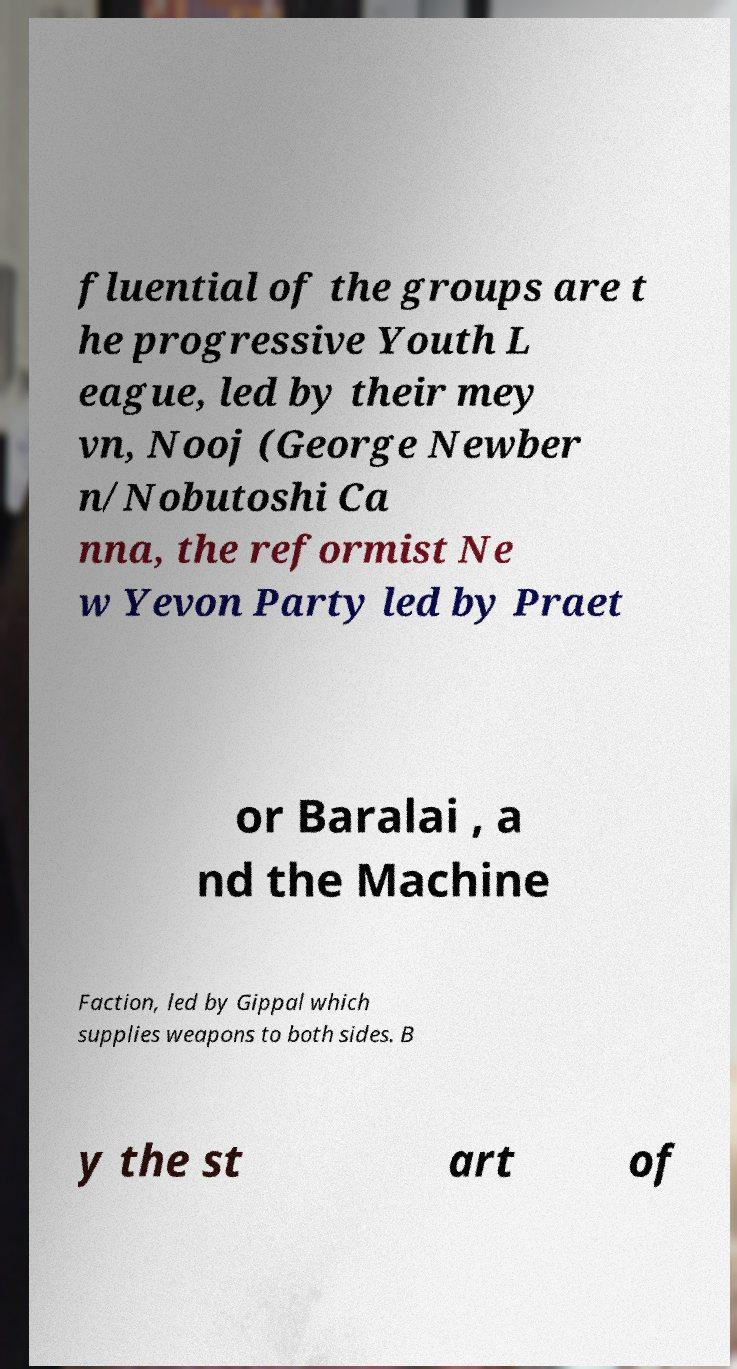Please read and relay the text visible in this image. What does it say? fluential of the groups are t he progressive Youth L eague, led by their mey vn, Nooj (George Newber n/Nobutoshi Ca nna, the reformist Ne w Yevon Party led by Praet or Baralai , a nd the Machine Faction, led by Gippal which supplies weapons to both sides. B y the st art of 